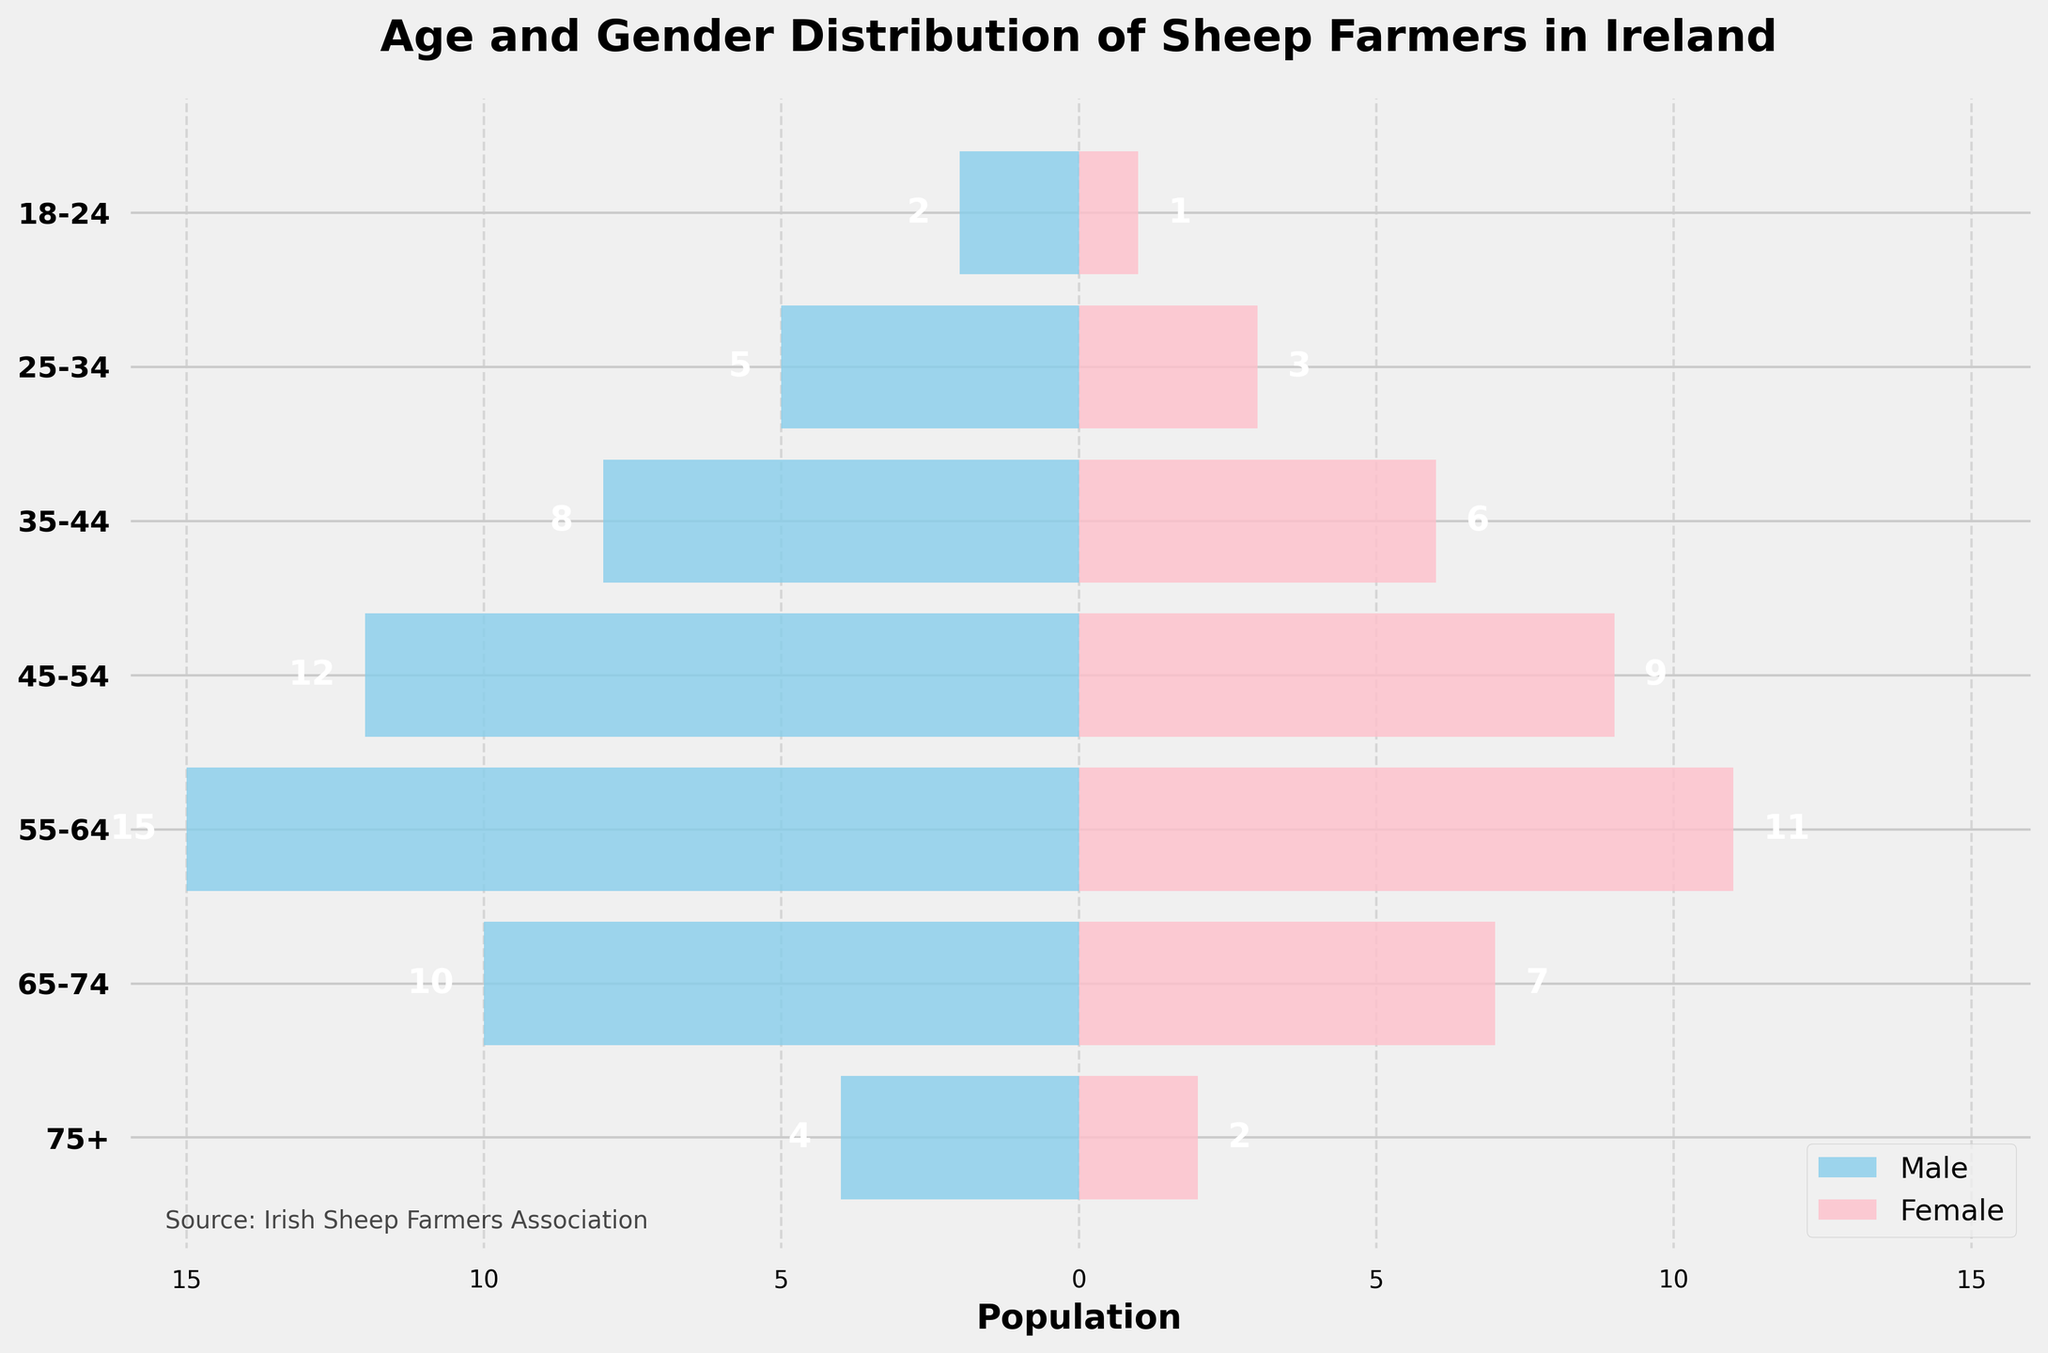What is the title of the figure? The title is usually displayed prominently at the top of the figure to provide an overview of what the chart represents.
Answer: Age and Gender Distribution of Sheep Farmers in Ireland How many age groups are represented in the figure? To find the number of age groups, count the distinct labels on the y-axis.
Answer: 7 Which age group has the most male sheep farmers? To find this, look for the largest negative bar value on the male side of the chart.
Answer: 55-64 How many female sheep farmers are in the 45-54 age group? Identify the bar that represents the 45-54 age group and read the value on the female side.
Answer: 9 What is the total number of male sheep farmers aged 55 and above? Sum the male values from the 55-64, 65-74, and 75+ age groups. 15 + 10 + 4 = 29.
Answer: 29 How does the number of female sheep farmers compare between the 18-24 and 75+ age groups? Compare the female values for the 18-24 and 75+ age groups. Both are small values but can be precisely read from the chart: 1 and 2 respectively.
Answer: There are more female sheep farmers aged 75+ than aged 18-24 What is the difference in the number of male and female sheep farmers in the 35-44 age group? Subtract the number of females from the number of males in the 35-44 age group. 8 - 6 = 2.
Answer: 2 Which gender has the higher overall number of sheep farmers in the plot? Add the values for both male and female across all age groups and compare the totals. Total of males: 2 + 5 + 8 + 12 + 15 + 10 + 4 = 56. Total of females: 1 + 3 + 6 + 9 + 11 + 7 + 2 = 39.
Answer: Male What is the most significant gender disparity in any single age group? Calculate the absolute difference for each age group and identify the largest difference. The differences are: 1, 2, 2, 3, 4, 3, 2. The largest is in the 55-64 age group with a difference of 4.
Answer: 55-64 age group In which age group is the number of female sheep farmers exactly half the number of male sheep farmers? Identify the age group where the female value is half of the male value. This occurs in the 18-24 age group, with 2 males and 1 female.
Answer: 18-24 